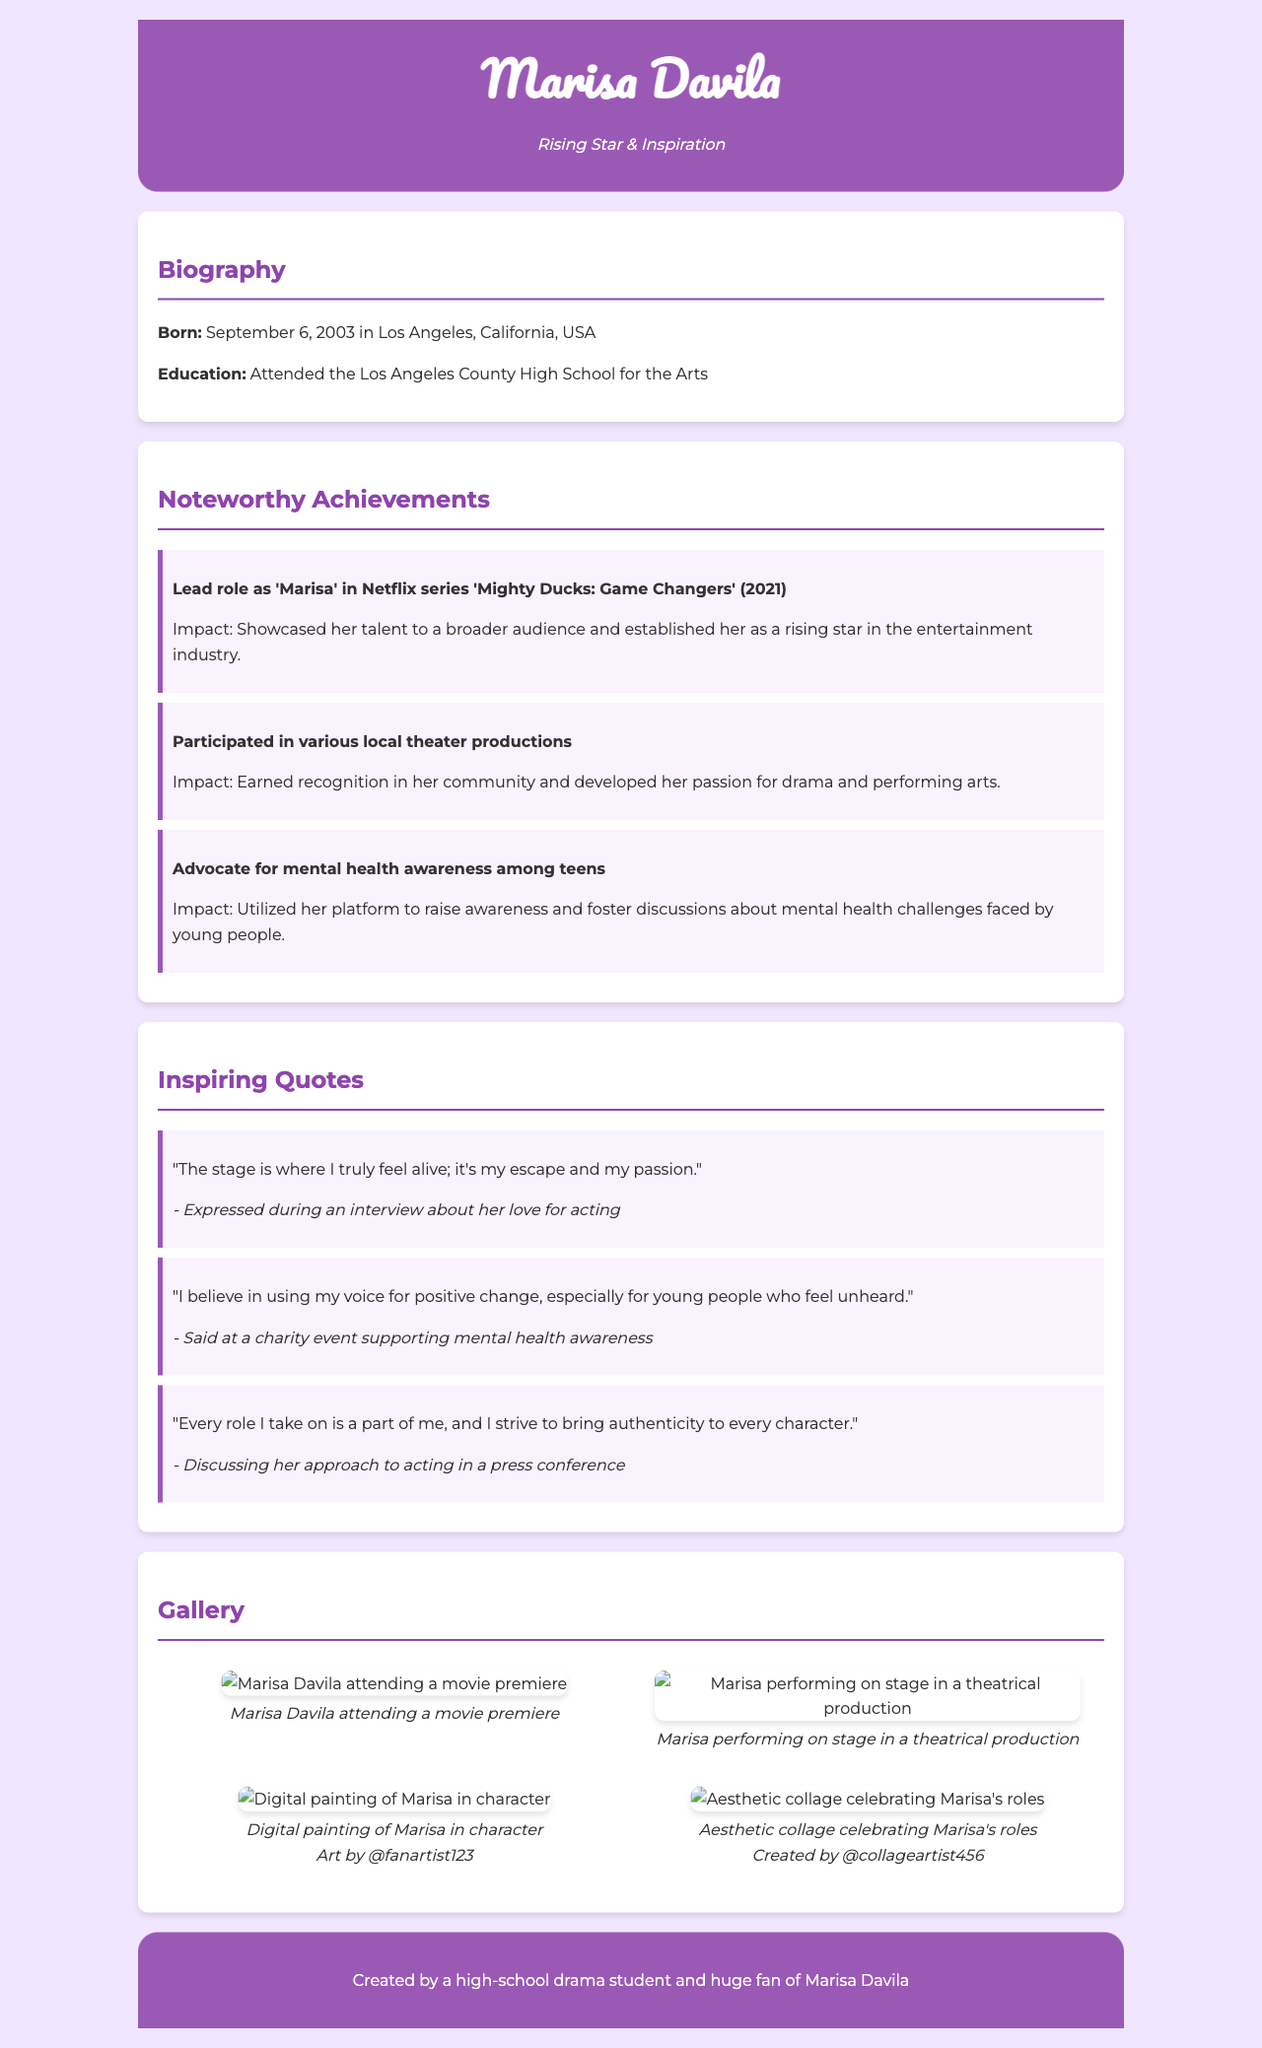What is Marisa Davila's birth date? The document states that Marisa Davila was born on September 6, 2003.
Answer: September 6, 2003 What is the title of the Netflix series in which Marisa played the lead role? The document mentions that Marisa played the lead role in "Mighty Ducks: Game Changers."
Answer: Mighty Ducks: Game Changers Which school did Marisa attend for her education? According to the biography section, Marisa attended the Los Angeles County High School for the Arts.
Answer: Los Angeles County High School for the Arts What is Marisa's role in advocating for mental health? The document notes that Marisa is an advocate for mental health awareness among teens.
Answer: Advocate for mental health awareness How many quotes are provided in the Inspiring Quotes section? The document includes three quotes from Marisa in the Inspiring Quotes section.
Answer: Three What impact did Marisa's role in 'Mighty Ducks' have? The impact mentioned in the document states it showcased her talent to a broader audience and established her as a rising star.
Answer: Broader audience and rising star Who created the aesthetic collage celebrating Marisa's roles? The document attributes the aesthetic collage to @collageartist456.
Answer: @collageartist456 What color is associated with the header background? The document describes the header background color as #9b59b6.
Answer: #9b59b6 What type of artwork appears in the gallery? The document features fan art and images of Marisa's performances in the gallery section.
Answer: Fan art and images 